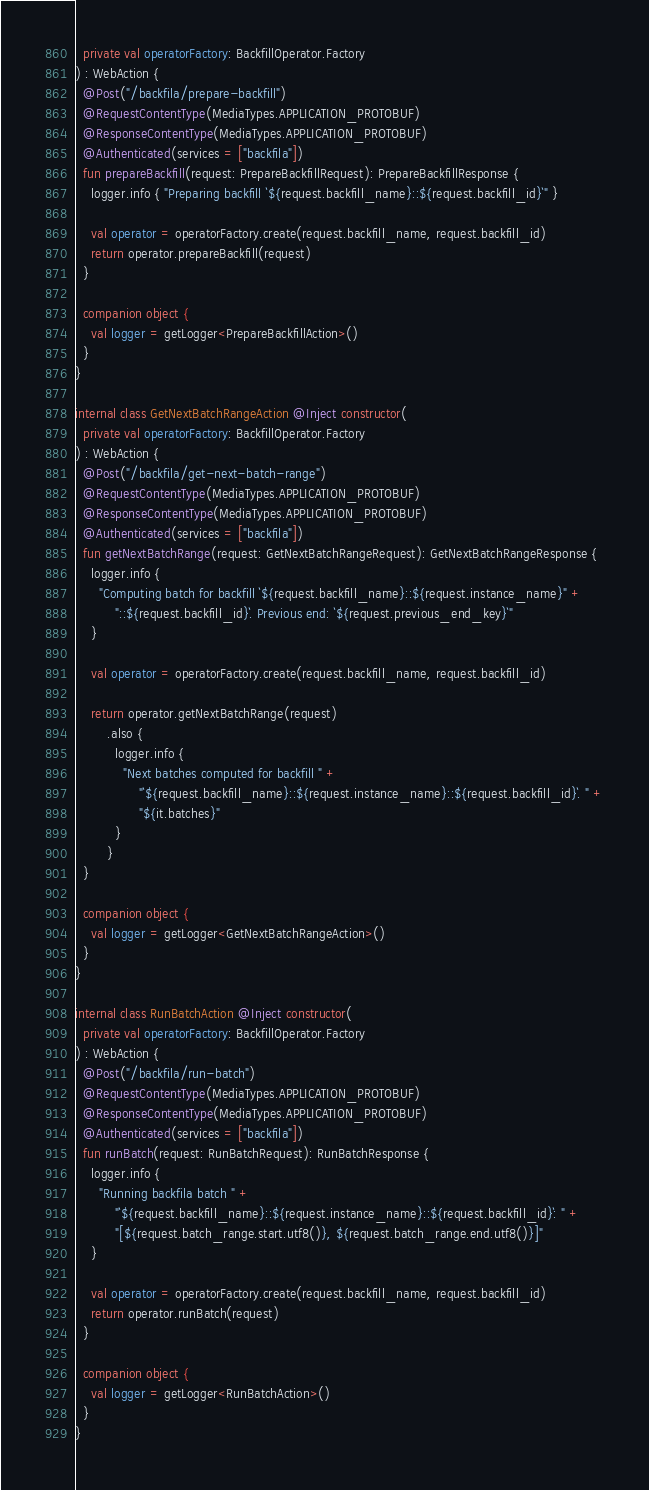<code> <loc_0><loc_0><loc_500><loc_500><_Kotlin_>  private val operatorFactory: BackfillOperator.Factory
) : WebAction {
  @Post("/backfila/prepare-backfill")
  @RequestContentType(MediaTypes.APPLICATION_PROTOBUF)
  @ResponseContentType(MediaTypes.APPLICATION_PROTOBUF)
  @Authenticated(services = ["backfila"])
  fun prepareBackfill(request: PrepareBackfillRequest): PrepareBackfillResponse {
    logger.info { "Preparing backfill `${request.backfill_name}::${request.backfill_id}`" }

    val operator = operatorFactory.create(request.backfill_name, request.backfill_id)
    return operator.prepareBackfill(request)
  }

  companion object {
    val logger = getLogger<PrepareBackfillAction>()
  }
}

internal class GetNextBatchRangeAction @Inject constructor(
  private val operatorFactory: BackfillOperator.Factory
) : WebAction {
  @Post("/backfila/get-next-batch-range")
  @RequestContentType(MediaTypes.APPLICATION_PROTOBUF)
  @ResponseContentType(MediaTypes.APPLICATION_PROTOBUF)
  @Authenticated(services = ["backfila"])
  fun getNextBatchRange(request: GetNextBatchRangeRequest): GetNextBatchRangeResponse {
    logger.info {
      "Computing batch for backfill `${request.backfill_name}::${request.instance_name}" +
          "::${request.backfill_id}`. Previous end: `${request.previous_end_key}`"
    }

    val operator = operatorFactory.create(request.backfill_name, request.backfill_id)

    return operator.getNextBatchRange(request)
        .also {
          logger.info {
            "Next batches computed for backfill " +
                "`${request.backfill_name}::${request.instance_name}::${request.backfill_id}`. " +
                "${it.batches}"
          }
        }
  }

  companion object {
    val logger = getLogger<GetNextBatchRangeAction>()
  }
}

internal class RunBatchAction @Inject constructor(
  private val operatorFactory: BackfillOperator.Factory
) : WebAction {
  @Post("/backfila/run-batch")
  @RequestContentType(MediaTypes.APPLICATION_PROTOBUF)
  @ResponseContentType(MediaTypes.APPLICATION_PROTOBUF)
  @Authenticated(services = ["backfila"])
  fun runBatch(request: RunBatchRequest): RunBatchResponse {
    logger.info {
      "Running backfila batch " +
          "`${request.backfill_name}::${request.instance_name}::${request.backfill_id}`: " +
          "[${request.batch_range.start.utf8()}, ${request.batch_range.end.utf8()}]"
    }

    val operator = operatorFactory.create(request.backfill_name, request.backfill_id)
    return operator.runBatch(request)
  }

  companion object {
    val logger = getLogger<RunBatchAction>()
  }
}
</code> 